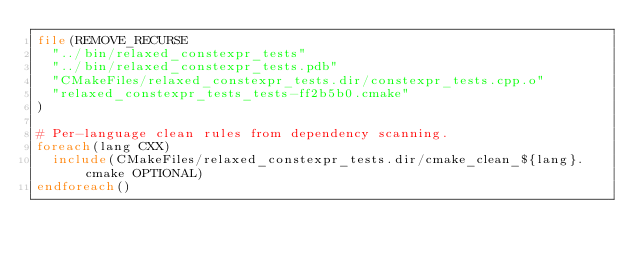Convert code to text. <code><loc_0><loc_0><loc_500><loc_500><_CMake_>file(REMOVE_RECURSE
  "../bin/relaxed_constexpr_tests"
  "../bin/relaxed_constexpr_tests.pdb"
  "CMakeFiles/relaxed_constexpr_tests.dir/constexpr_tests.cpp.o"
  "relaxed_constexpr_tests_tests-ff2b5b0.cmake"
)

# Per-language clean rules from dependency scanning.
foreach(lang CXX)
  include(CMakeFiles/relaxed_constexpr_tests.dir/cmake_clean_${lang}.cmake OPTIONAL)
endforeach()
</code> 